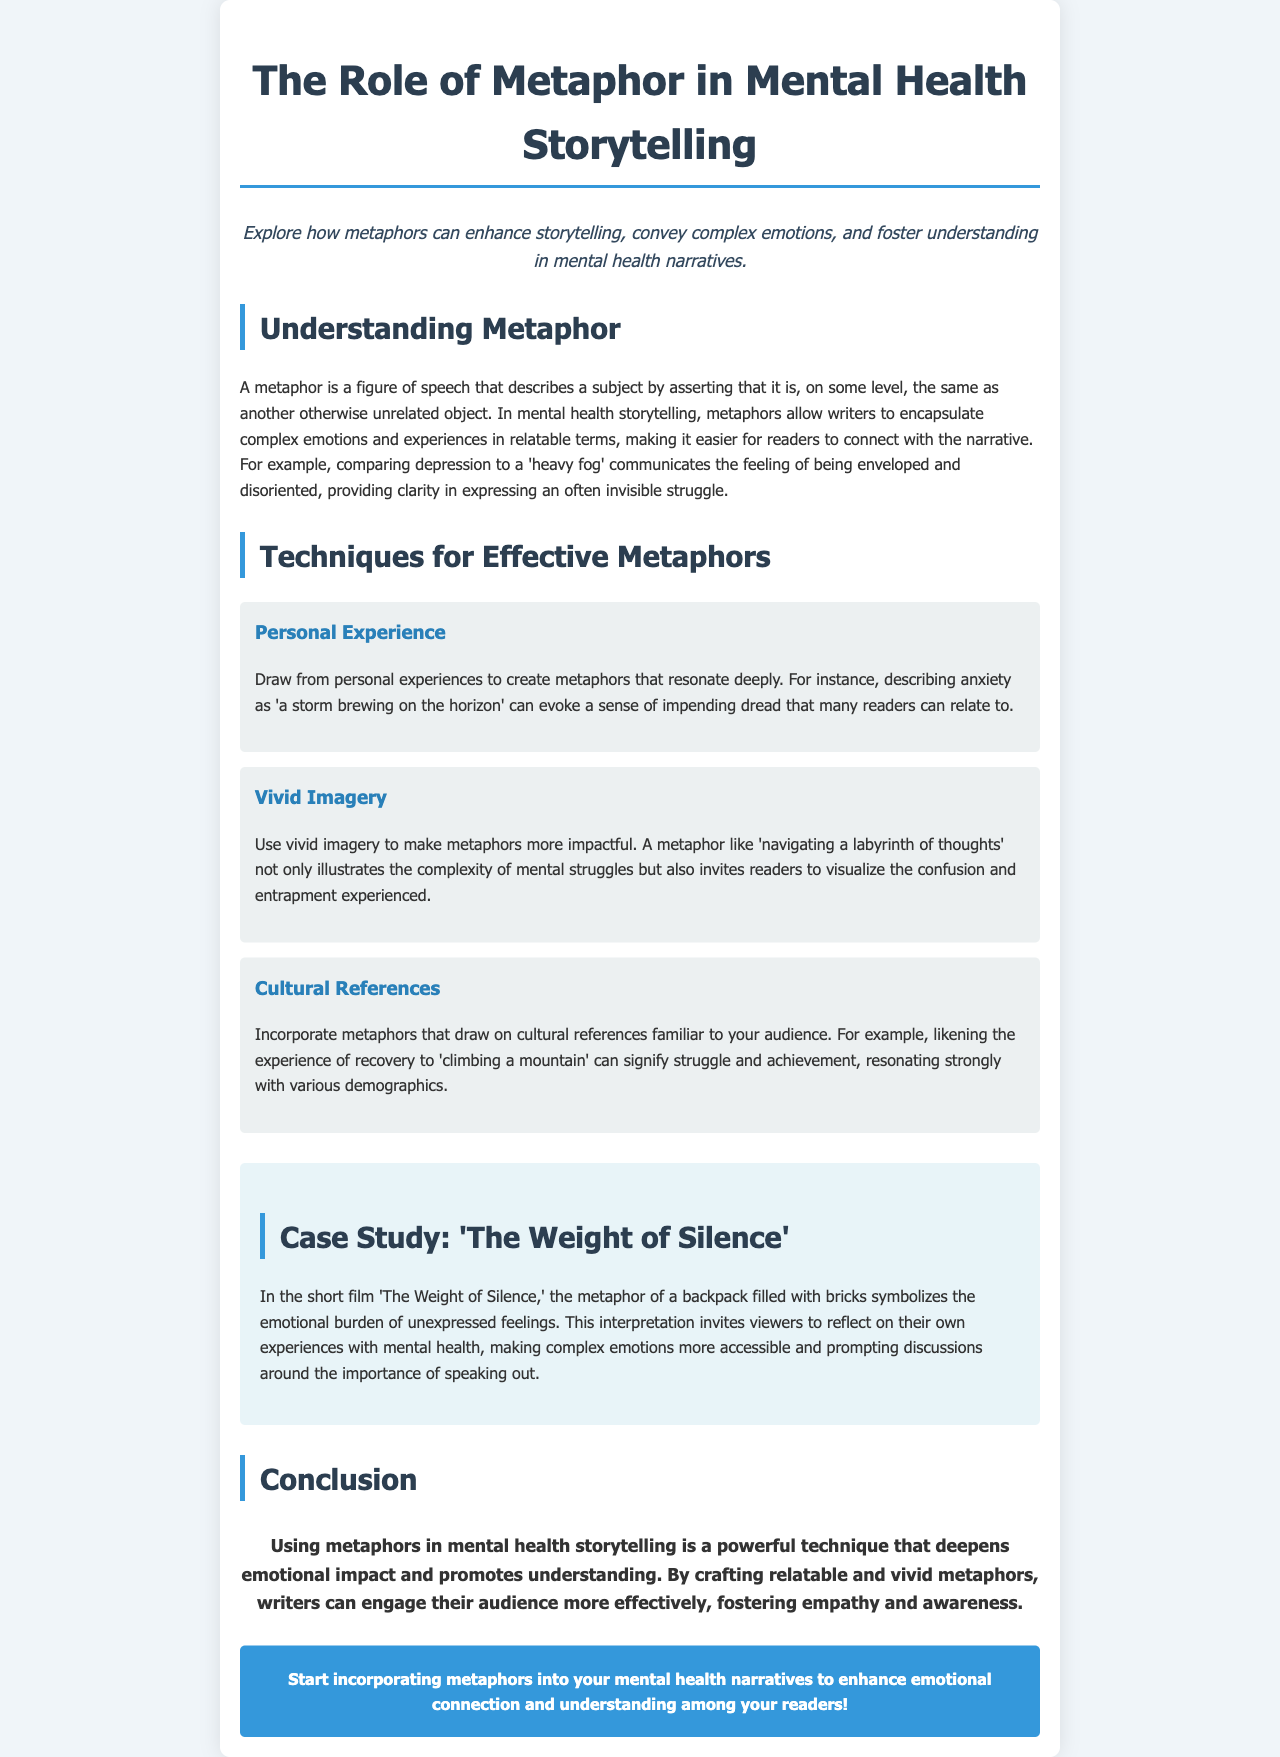What is the title of the document? The title is stated prominently at the top of the document.
Answer: The Role of Metaphor in Mental Health Storytelling What is the metaphor described for depression? The document provides an example metaphor specifically for depression.
Answer: heavy fog What technique involves drawing from personal experiences? A specific technique is highlighted under the techniques for effective metaphors.
Answer: Personal Experience What cultural reference is used in the document? The document mentions a cultural reference to illustrate a metaphor.
Answer: climbing a mountain What is the name of the case study mentioned? The document refers to a specific case study that illustrates a metaphor.
Answer: The Weight of Silence What does the metaphor of a backpack filled with bricks symbolize? The document explains the symbolism behind this metaphor within the case study.
Answer: emotional burden of unexpressed feelings What is the message encouraged in the call to action? The call to action provides guidance to writers regarding metaphor use.
Answer: Start incorporating metaphors into your mental health narratives How many techniques for effective metaphors are listed? The document outlines several techniques under a specific section.
Answer: three 